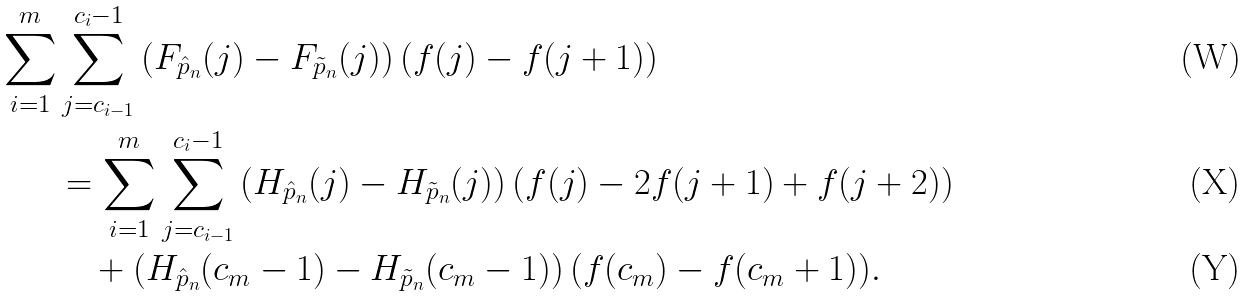Convert formula to latex. <formula><loc_0><loc_0><loc_500><loc_500>\sum _ { i = 1 } ^ { m } & \sum _ { j = c _ { i - 1 } } ^ { c _ { i } - 1 } \left ( F _ { \hat { p } _ { n } } ( j ) - F _ { \tilde { p } _ { n } } ( j ) \right ) \left ( f ( j ) - f ( j + 1 ) \right ) \\ & = \sum _ { i = 1 } ^ { m } \sum _ { j = c _ { i - 1 } } ^ { c _ { i } - 1 } \left ( H _ { \hat { p } _ { n } } ( j ) - H _ { \tilde { p } _ { n } } ( j ) \right ) \left ( f ( j ) - 2 f ( j + 1 ) + f ( j + 2 ) \right ) \\ & \quad + \left ( H _ { \hat { p } _ { n } } ( c _ { m } - 1 ) - H _ { \tilde { p } _ { n } } ( c _ { m } - 1 ) \right ) ( f ( c _ { m } ) - f ( c _ { m } + 1 ) ) .</formula> 